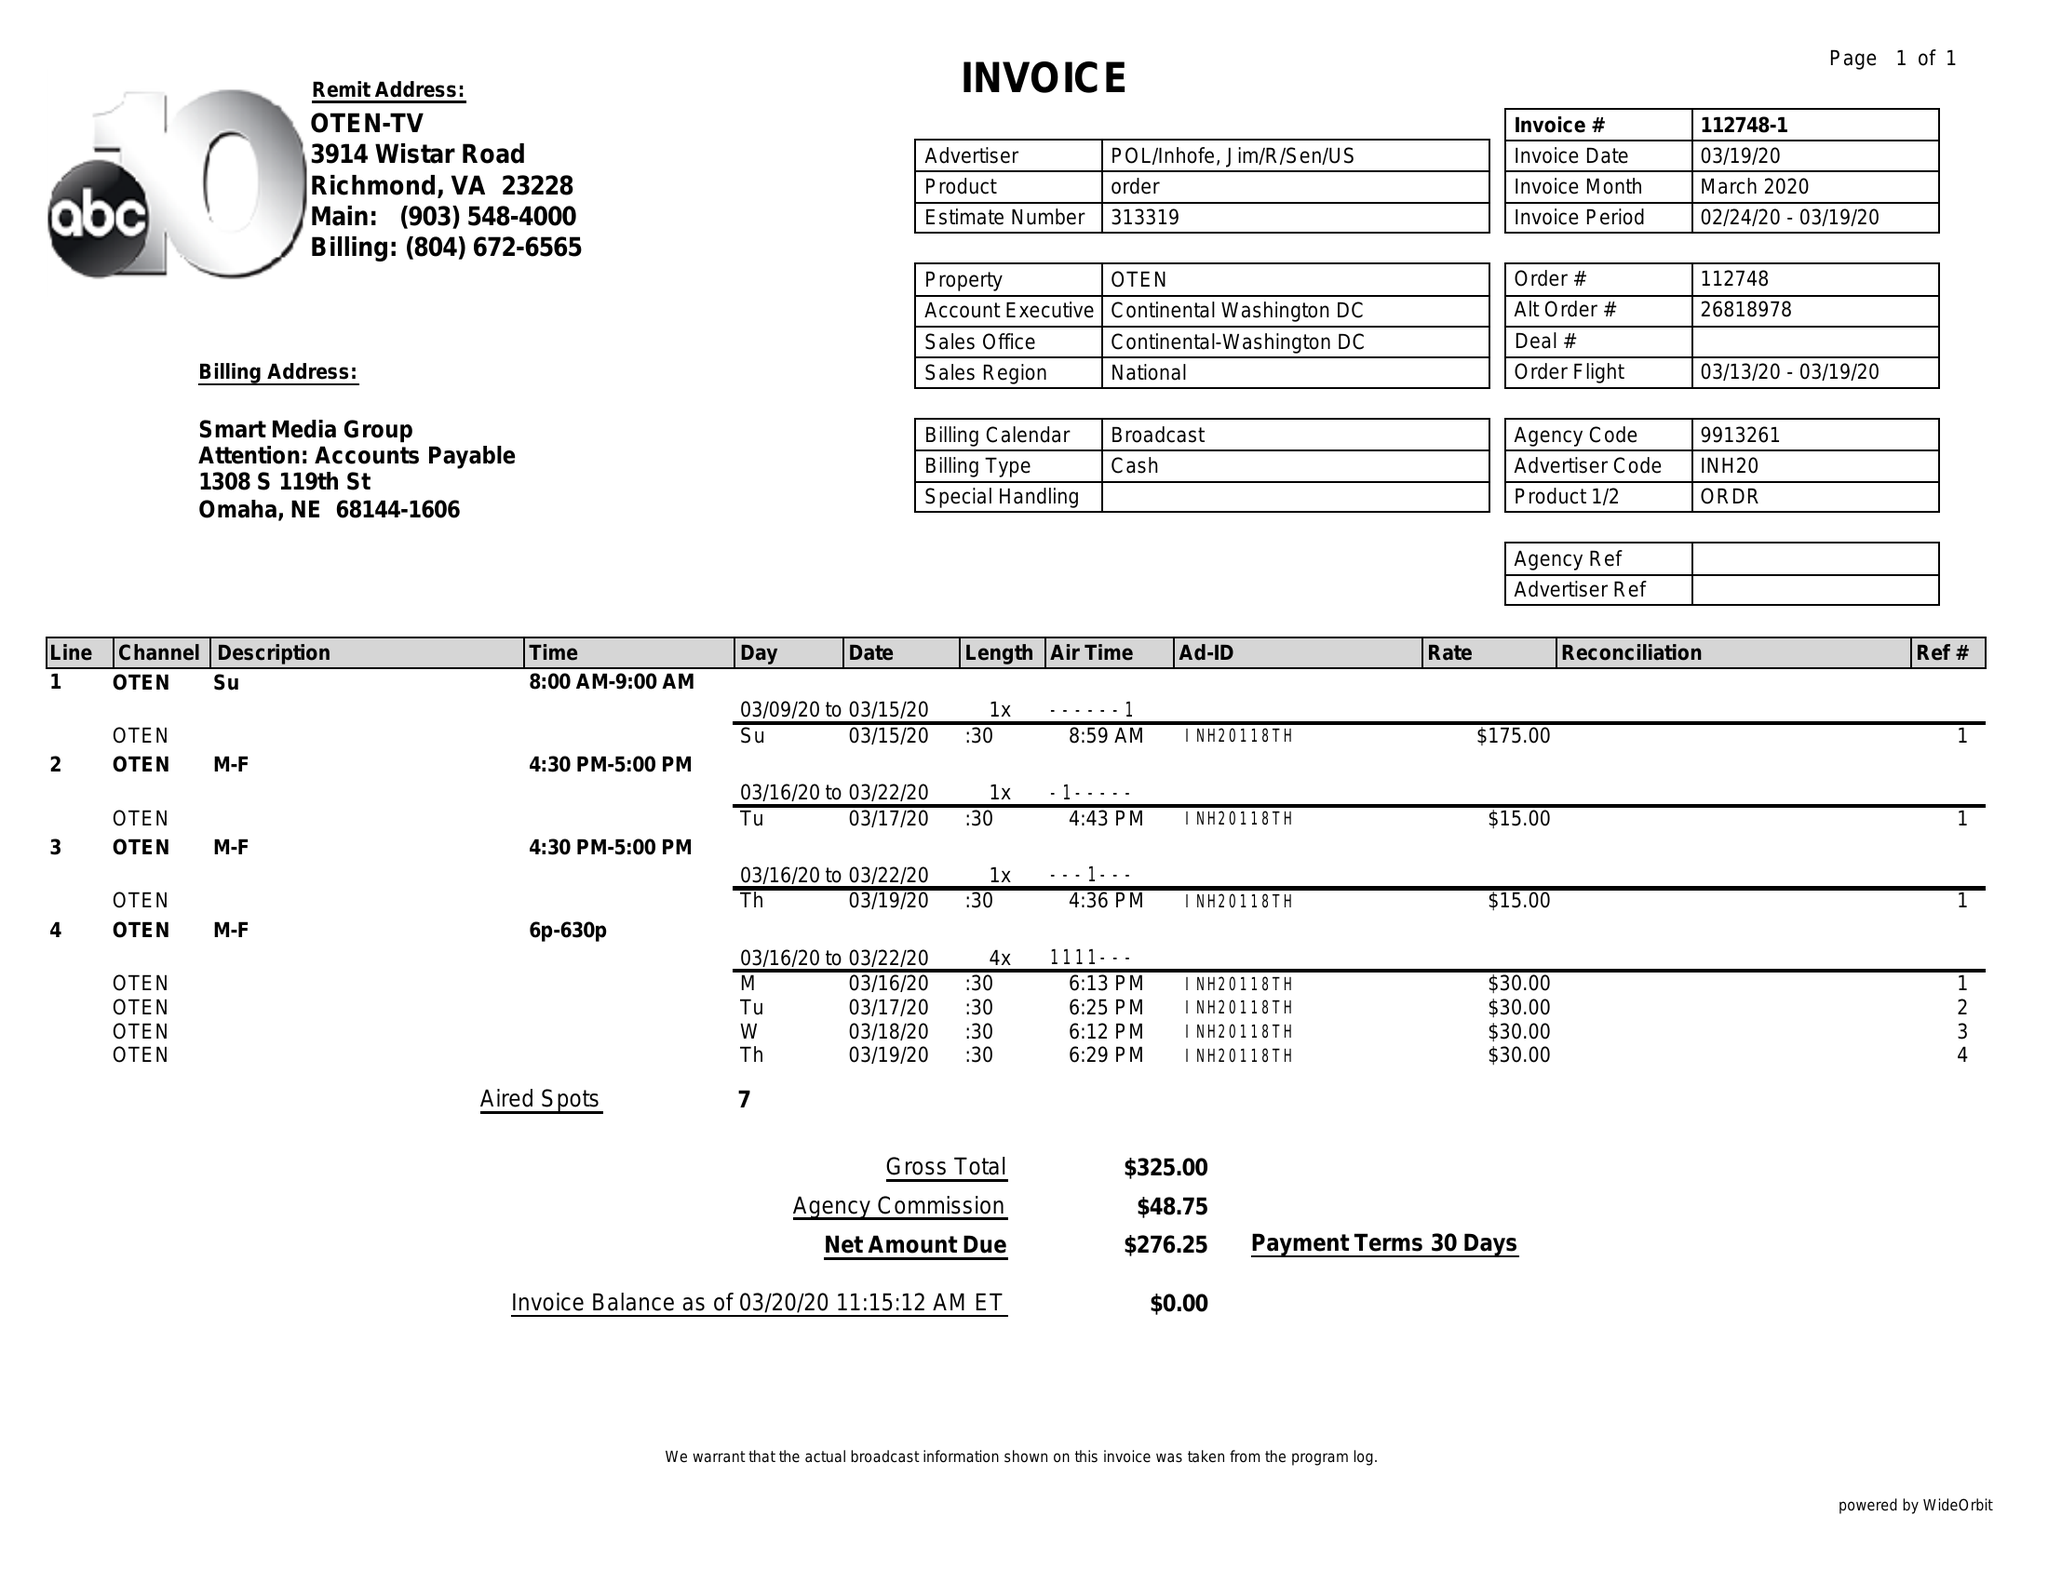What is the value for the flight_to?
Answer the question using a single word or phrase. 03/19/20 